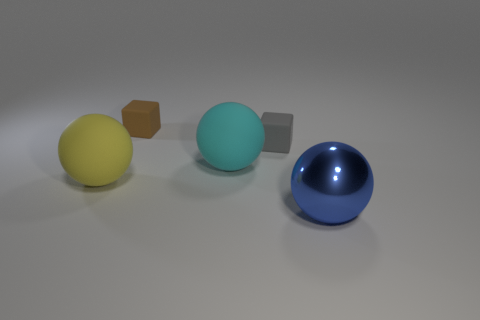Subtract 1 balls. How many balls are left? 2 Subtract all matte spheres. How many spheres are left? 1 Add 3 gray matte blocks. How many objects exist? 8 Subtract all blocks. How many objects are left? 3 Subtract 0 purple blocks. How many objects are left? 5 Subtract all tiny red cubes. Subtract all large blue things. How many objects are left? 4 Add 1 small objects. How many small objects are left? 3 Add 1 brown rubber objects. How many brown rubber objects exist? 2 